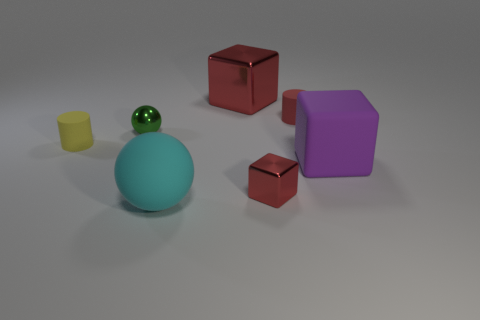Subtract 1 blocks. How many blocks are left? 2 Add 1 cyan rubber balls. How many objects exist? 8 Subtract all balls. How many objects are left? 5 Subtract 1 red cylinders. How many objects are left? 6 Subtract all red cylinders. Subtract all rubber balls. How many objects are left? 5 Add 7 tiny blocks. How many tiny blocks are left? 8 Add 6 tiny green balls. How many tiny green balls exist? 7 